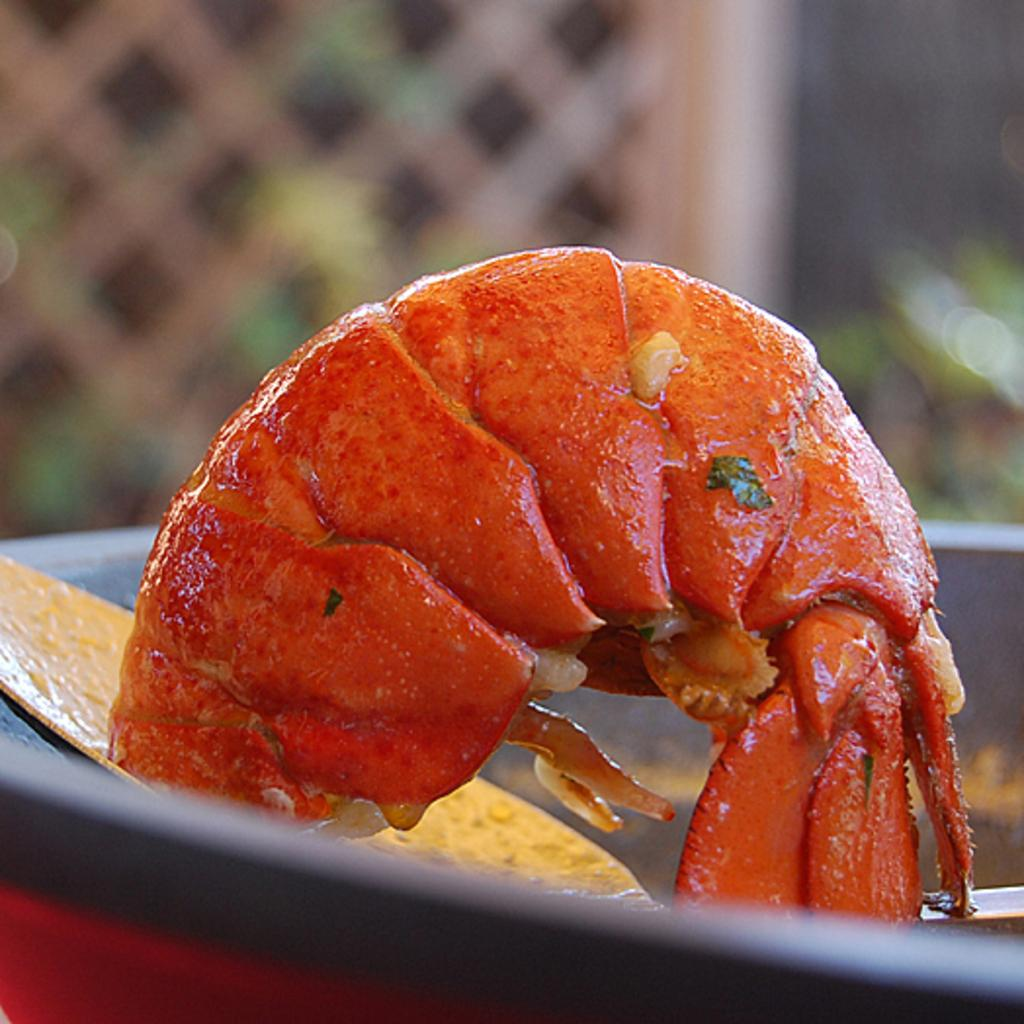What is the main subject of the image? The main subject of the image is a shrimp. Where is the shrimp located in the image? The shrimp is in an object. Can you describe the background of the image? The background of the image is blurred. What type of voyage is the shrimp embarking on in the image? There is no indication of a voyage in the image; the shrimp is simply located in an object. How does the shrimp sort the items in the image? There are no items to sort in the image, as the main subject is the shrimp itself. 